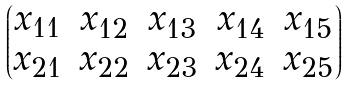Convert formula to latex. <formula><loc_0><loc_0><loc_500><loc_500>\begin{pmatrix} x _ { 1 1 } & x _ { 1 2 } & x _ { 1 3 } & x _ { 1 4 } & x _ { 1 5 } \\ x _ { 2 1 } & x _ { 2 2 } & x _ { 2 3 } & x _ { 2 4 } & x _ { 2 5 } \end{pmatrix}</formula> 